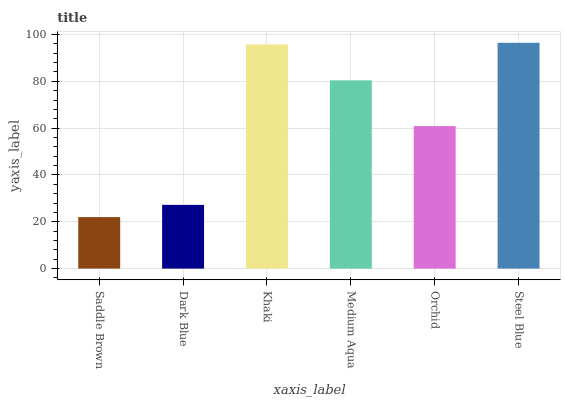Is Saddle Brown the minimum?
Answer yes or no. Yes. Is Steel Blue the maximum?
Answer yes or no. Yes. Is Dark Blue the minimum?
Answer yes or no. No. Is Dark Blue the maximum?
Answer yes or no. No. Is Dark Blue greater than Saddle Brown?
Answer yes or no. Yes. Is Saddle Brown less than Dark Blue?
Answer yes or no. Yes. Is Saddle Brown greater than Dark Blue?
Answer yes or no. No. Is Dark Blue less than Saddle Brown?
Answer yes or no. No. Is Medium Aqua the high median?
Answer yes or no. Yes. Is Orchid the low median?
Answer yes or no. Yes. Is Steel Blue the high median?
Answer yes or no. No. Is Saddle Brown the low median?
Answer yes or no. No. 